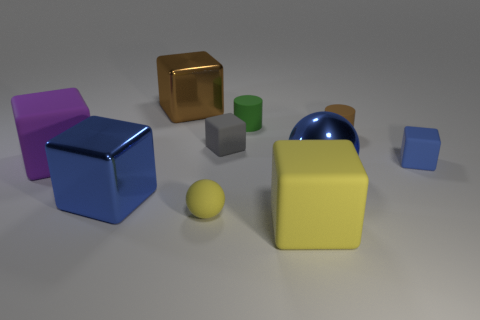Subtract all green cylinders. How many cylinders are left? 1 Subtract all tiny gray rubber cubes. How many cubes are left? 5 Subtract 5 cubes. How many cubes are left? 1 Subtract all cyan cylinders. Subtract all green spheres. How many cylinders are left? 2 Subtract all brown spheres. How many red cylinders are left? 0 Add 1 tiny rubber cylinders. How many tiny rubber cylinders exist? 3 Subtract 0 yellow cylinders. How many objects are left? 10 Subtract all cubes. How many objects are left? 4 Subtract all green cylinders. Subtract all tiny yellow balls. How many objects are left? 8 Add 1 big purple objects. How many big purple objects are left? 2 